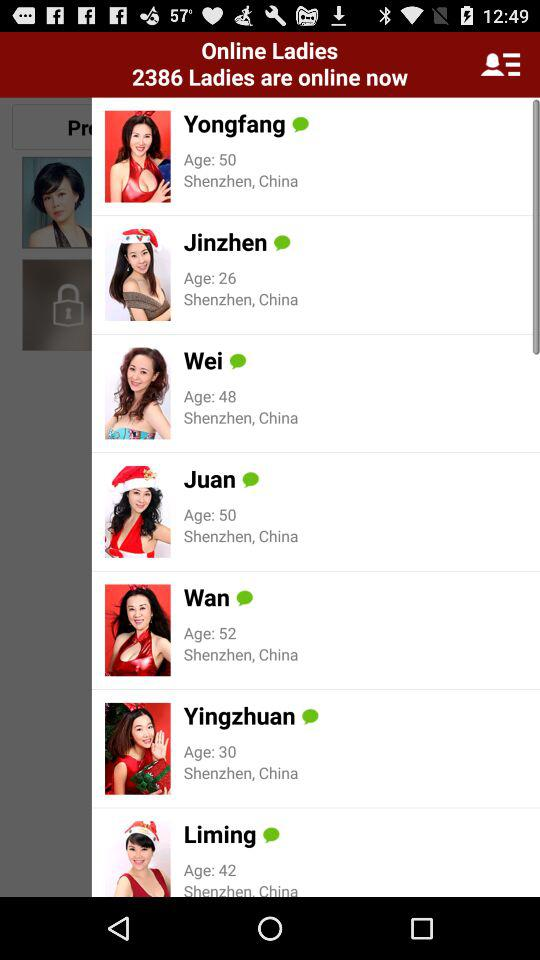What is the location of Wei? The location is "Shenzhen, China". 